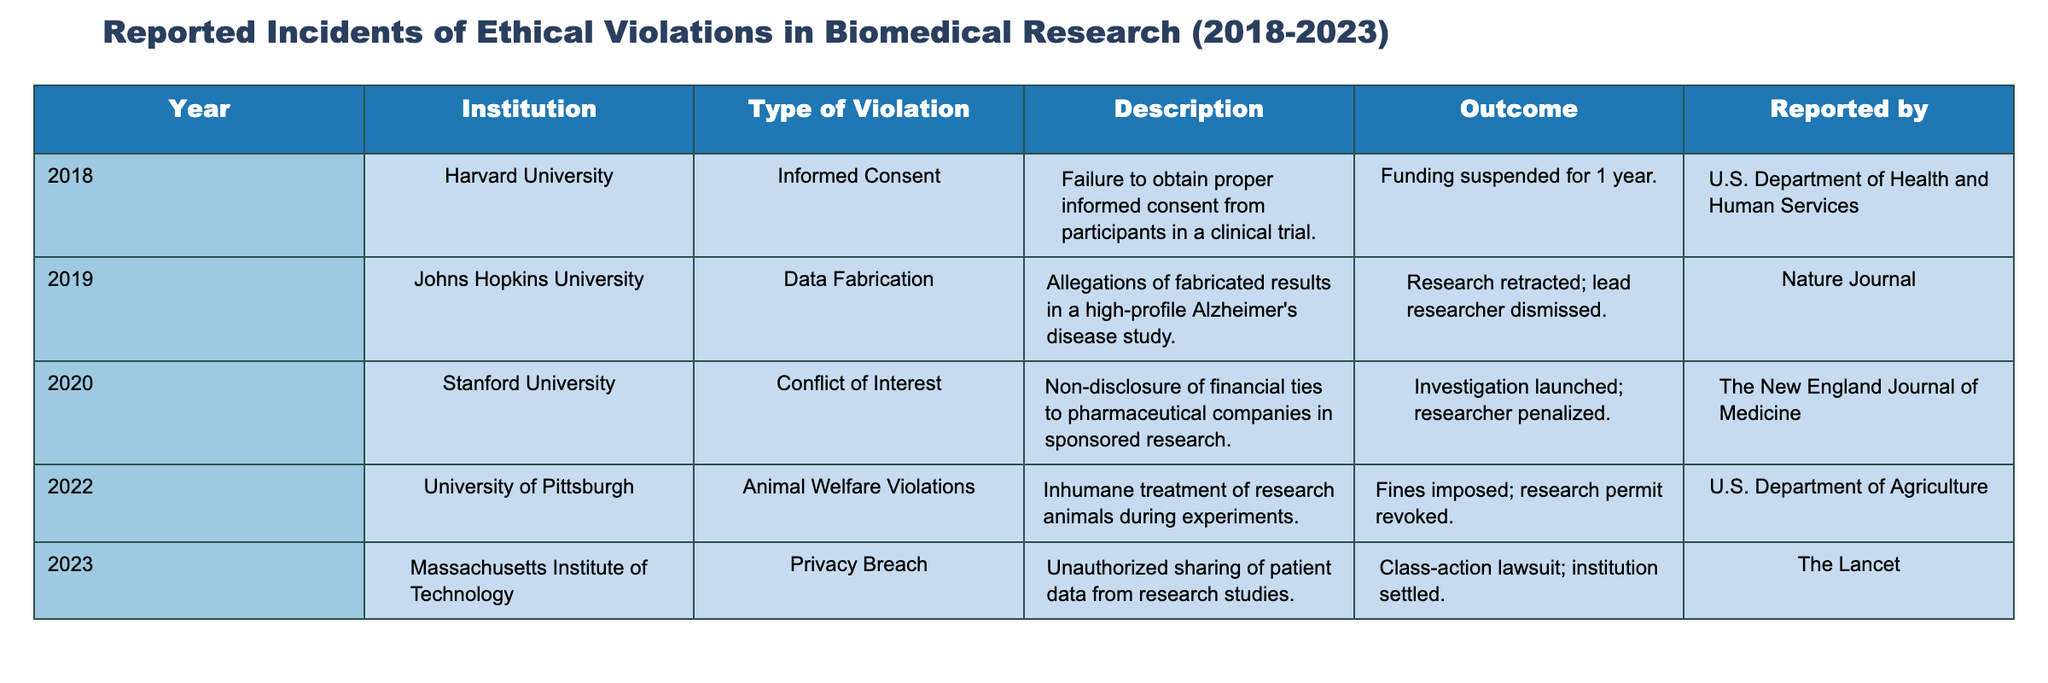What institution reported a privacy breach in 2023? The table shows that the Massachusetts Institute of Technology reported a privacy breach in 2023.
Answer: Massachusetts Institute of Technology How many incidents involved violations of informed consent? Referring to the table, only one incident in 2018 involved a violation of informed consent at Harvard University.
Answer: 1 What was the outcome of the data fabrication incident reported by Johns Hopkins University? According to the table, the outcome for the data fabrication incident was that the research was retracted and the lead researcher was dismissed.
Answer: Research retracted; lead researcher dismissed True or False: There were more animal welfare violations than privacy breaches reported. The table shows one incident of animal welfare violations in 2022 and one incident of a privacy breach in 2023, so the statement is false.
Answer: False What is the total number of reported incidents of ethical violations from 2018 to 2023? By counting each row in the table, there are a total of 5 reported incidents from 2018 to 2023.
Answer: 5 Which type of violation had the most severe outcome, and what was it? The table indicates that the animal welfare violations in 2022 had a severe outcome of fines imposed and research permit revoked, though the data fabrication incident also resulted in the lead researcher being dismissed. In terms of institutional impact, the animal welfare violation appears to be severe.
Answer: Animal Welfare Violations; fines imposed and research permit revoked How many different types of violations are reported in total? By analyzing the table, there are 5 different types of violations: informed consent, data fabrication, conflict of interest, animal welfare violations, and privacy breach.
Answer: 5 What institution was penalized for conflict of interest and what was the action taken? The table states that Stanford University was penalized for conflict of interest, and an investigation was launched leading to penalties for the researcher involved.
Answer: Investigation launched; researcher penalized 